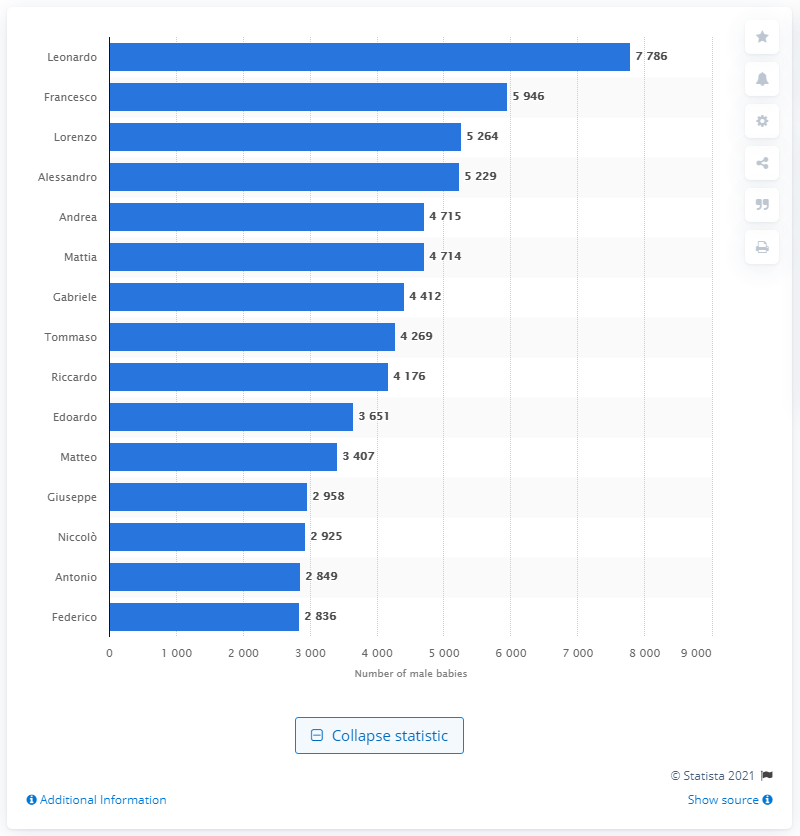Draw attention to some important aspects in this diagram. The most popular male name in Italy is Leonardo. There were 7,786 children in Italy named Leonardo in 2019. 